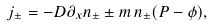<formula> <loc_0><loc_0><loc_500><loc_500>j _ { \pm } = - D \partial _ { x } n _ { \pm } \pm m \, n _ { \pm } ( P - \phi ) ,</formula> 